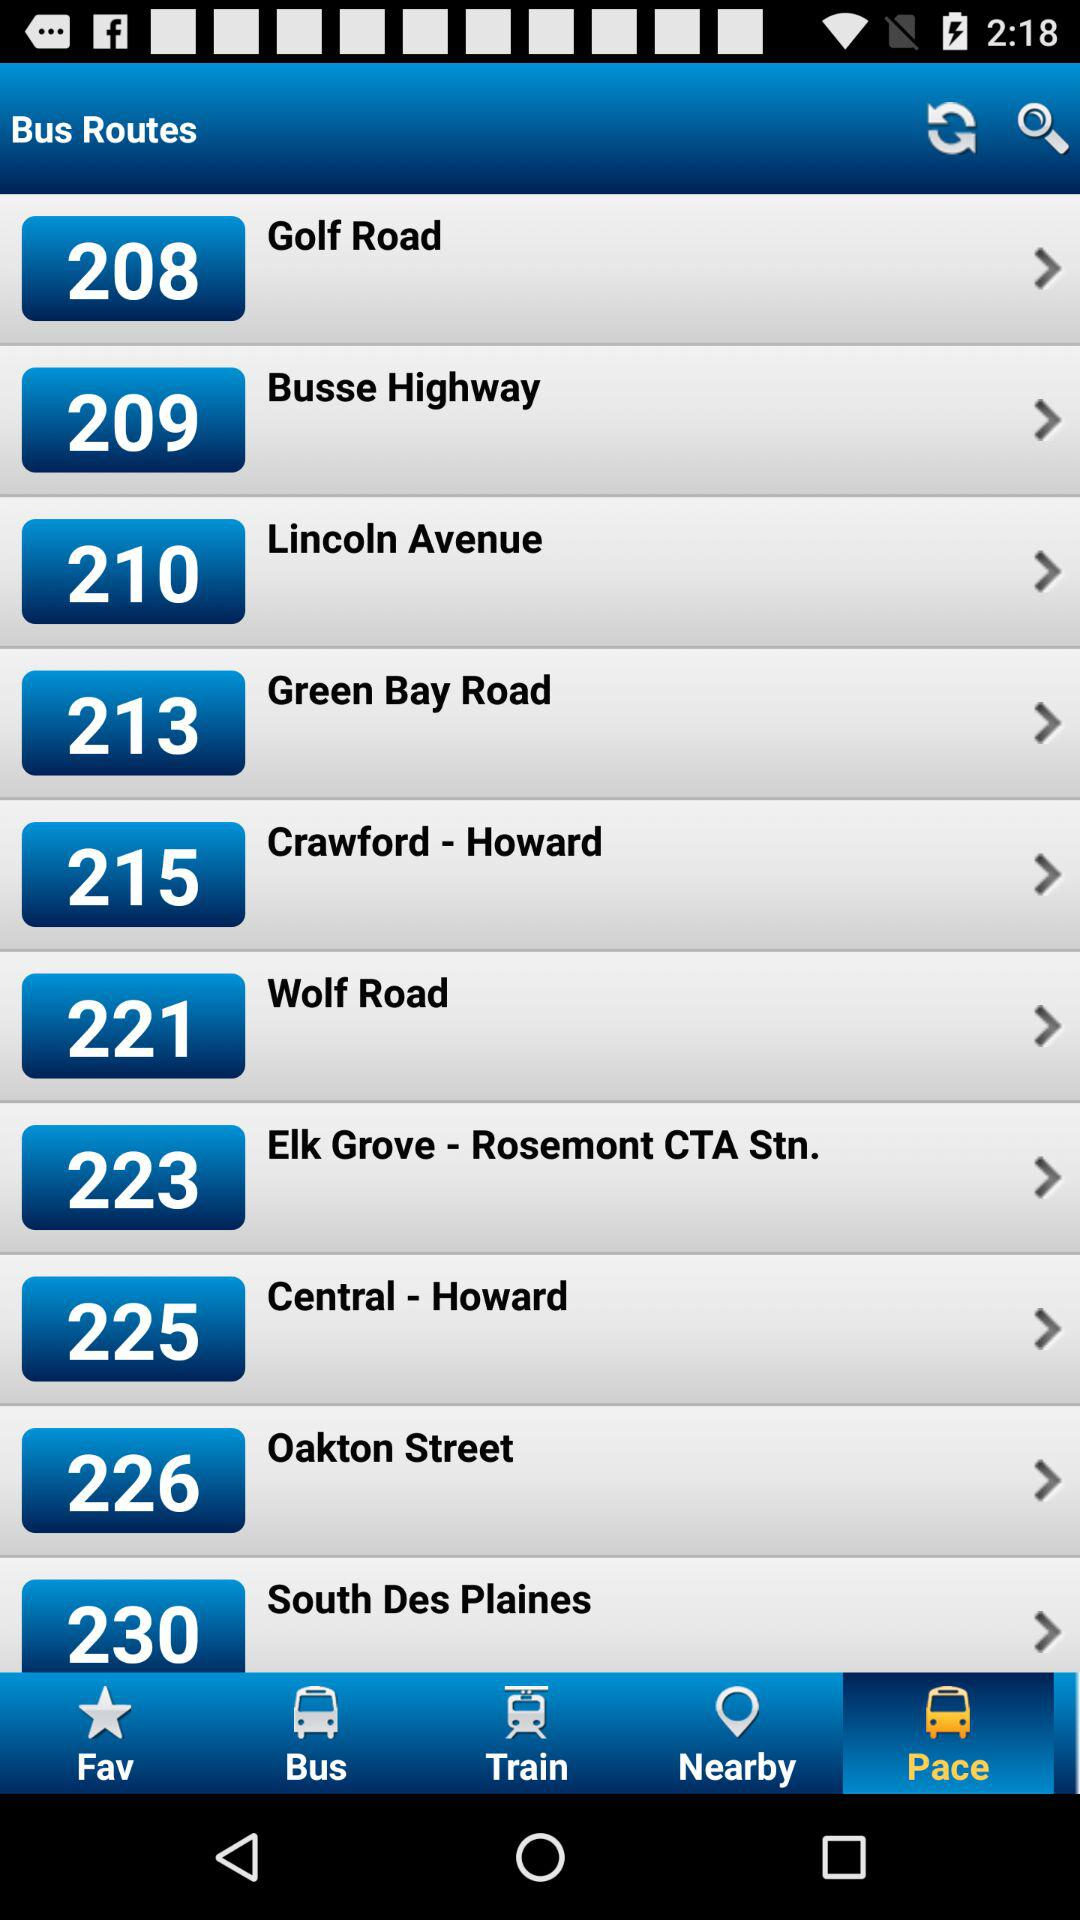How might I find out the exact schedules and frequency of these buses? To get the exact schedules and frequency for the bus routes shown, you would need to visit the transport company's official website, use their mobile application, or refer to the information provided at the bus stops. These resources typically provide up-to-date schedules and other pertinent details concerning route operations. 